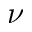<formula> <loc_0><loc_0><loc_500><loc_500>\nu</formula> 